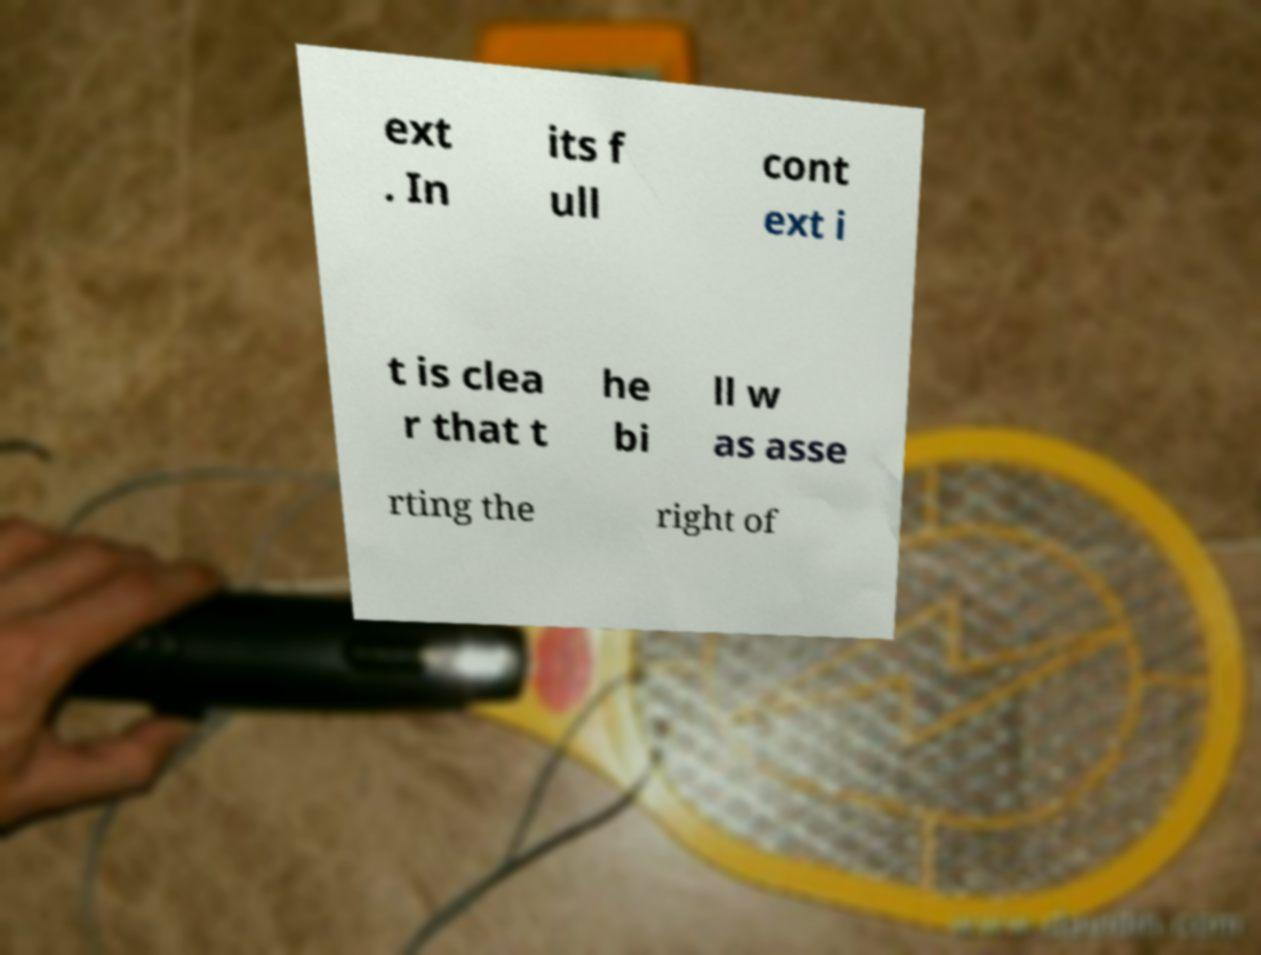Please read and relay the text visible in this image. What does it say? ext . In its f ull cont ext i t is clea r that t he bi ll w as asse rting the right of 